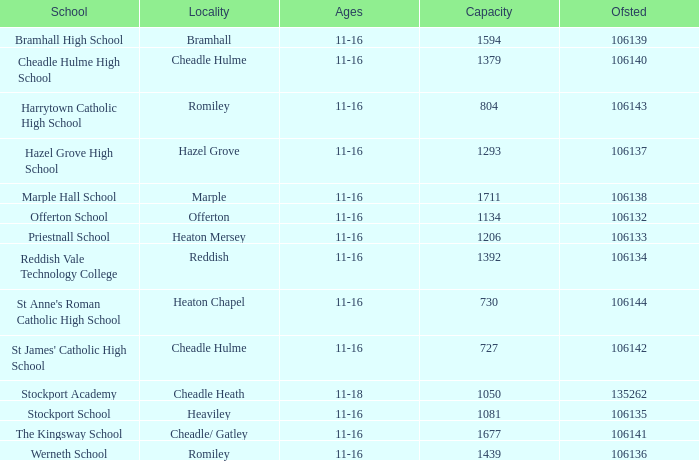Which Ofsted has a Capacity of 1677? 106141.0. 